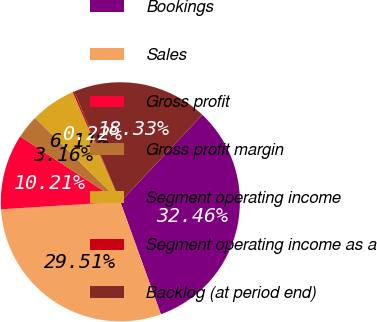Convert chart. <chart><loc_0><loc_0><loc_500><loc_500><pie_chart><fcel>Bookings<fcel>Sales<fcel>Gross profit<fcel>Gross profit margin<fcel>Segment operating income<fcel>Segment operating income as a<fcel>Backlog (at period end)<nl><fcel>32.46%<fcel>29.51%<fcel>10.21%<fcel>3.16%<fcel>6.11%<fcel>0.22%<fcel>18.33%<nl></chart> 